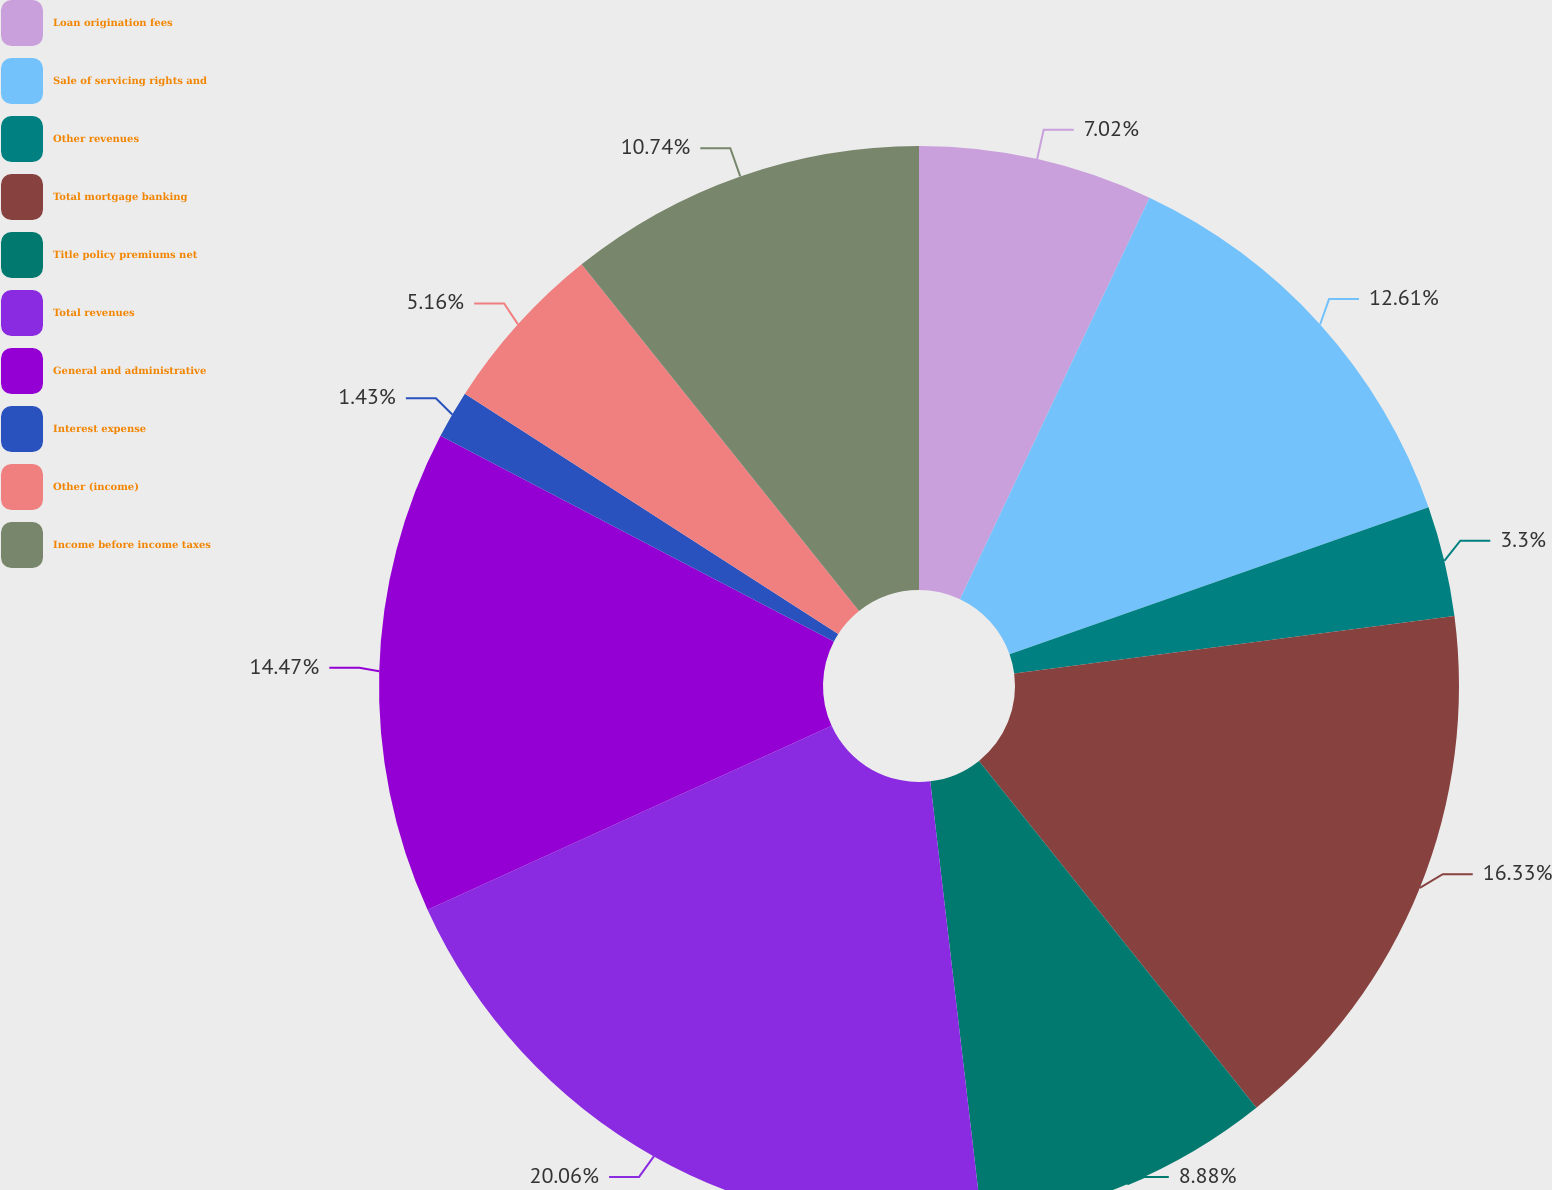Convert chart. <chart><loc_0><loc_0><loc_500><loc_500><pie_chart><fcel>Loan origination fees<fcel>Sale of servicing rights and<fcel>Other revenues<fcel>Total mortgage banking<fcel>Title policy premiums net<fcel>Total revenues<fcel>General and administrative<fcel>Interest expense<fcel>Other (income)<fcel>Income before income taxes<nl><fcel>7.02%<fcel>12.61%<fcel>3.3%<fcel>16.33%<fcel>8.88%<fcel>20.06%<fcel>14.47%<fcel>1.43%<fcel>5.16%<fcel>10.74%<nl></chart> 